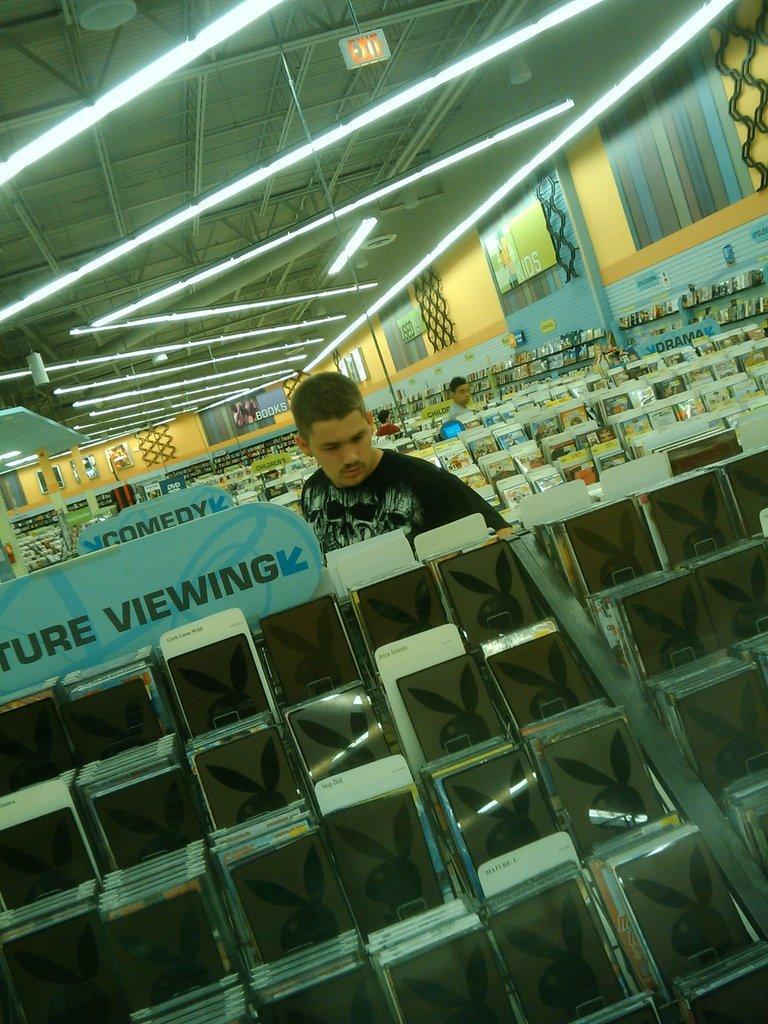Describe this image in one or two sentences. In this picture I can observe a man in the middle of the picture. In front of him I can observe few things which are looking like electronic devices. I can observe some lights hanging to the ceiling. 